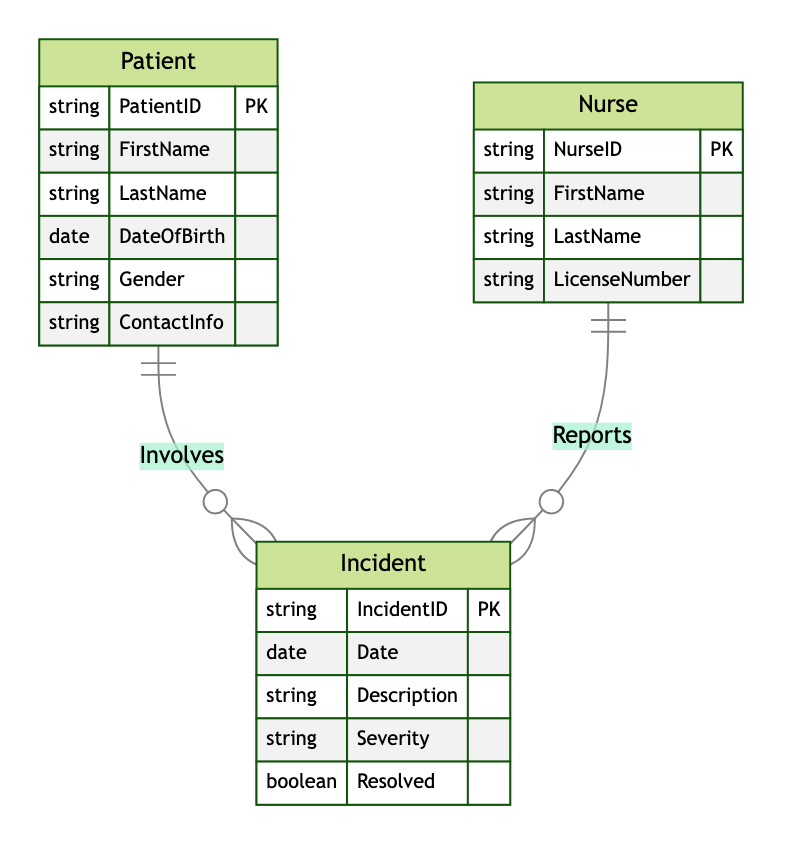What is the primary key of the Patient entity? The primary key for the Patient entity is identified in the diagram as PatientID, which uniquely identifies each patient in the system.
Answer: PatientID How many attributes does the Incident entity have? The Incident entity has five attributes: IncidentID, Date, Description, Severity, and Resolved, which can be counted by observing the attributes listed under the Incident entity in the diagram.
Answer: 5 Which entity reports incidents? The entity that reports incidents is represented as Nurse in the diagram, which is connected to the Incident entity indicating the reporting relationship.
Answer: Nurse What type of relationship exists between Patient and Incident? The relationship between Patient and Incident is a one-to-many relationship, denoted by the symbols in the diagram which indicate that one patient can be involved in multiple incidents.
Answer: one-to-many How many entities are shown in the diagram? There are three entities presented in the diagram: Patient, Incident, and Nurse. This can be determined by counting the distinct entities listed at the top of the diagram structure.
Answer: 3 What does the severity attribute signify in the context of an Incident? The severity attribute describes the level of seriousness of the incident, which helps in categorizing the incident's impact and urgency for response, as indicated in the attributes of the Incident entity.
Answer: seriousness Which entity has a relationship with both Nurse and Incident? The Incident entity has relationships with both the Nurse and Patient entities, as it is involved in reporting by Nurses and comprised of details pertaining to Patients.
Answer: Incident What is indicated by the "Reports" relationship? The "Reports" relationship indicates that each Nurse can report multiple incidents, while each incident is reported by only one Nurse, reflecting the one-to-many nature of the relationship.
Answer: one-to-many What is the primary key of the Nurse entity? The Nurse entity's primary key is NurseID, which uniquely identifies each nurse within the reporting system. This is explicitly shown in the diagram under the attributes of the Nurse entity.
Answer: NurseID How many relationships are depicted in the diagram? There are two relationships depicted in the diagram: "Reports" and "Involves," which can be confirmed by identifying the relationship lines that connect the entities within the diagram.
Answer: 2 